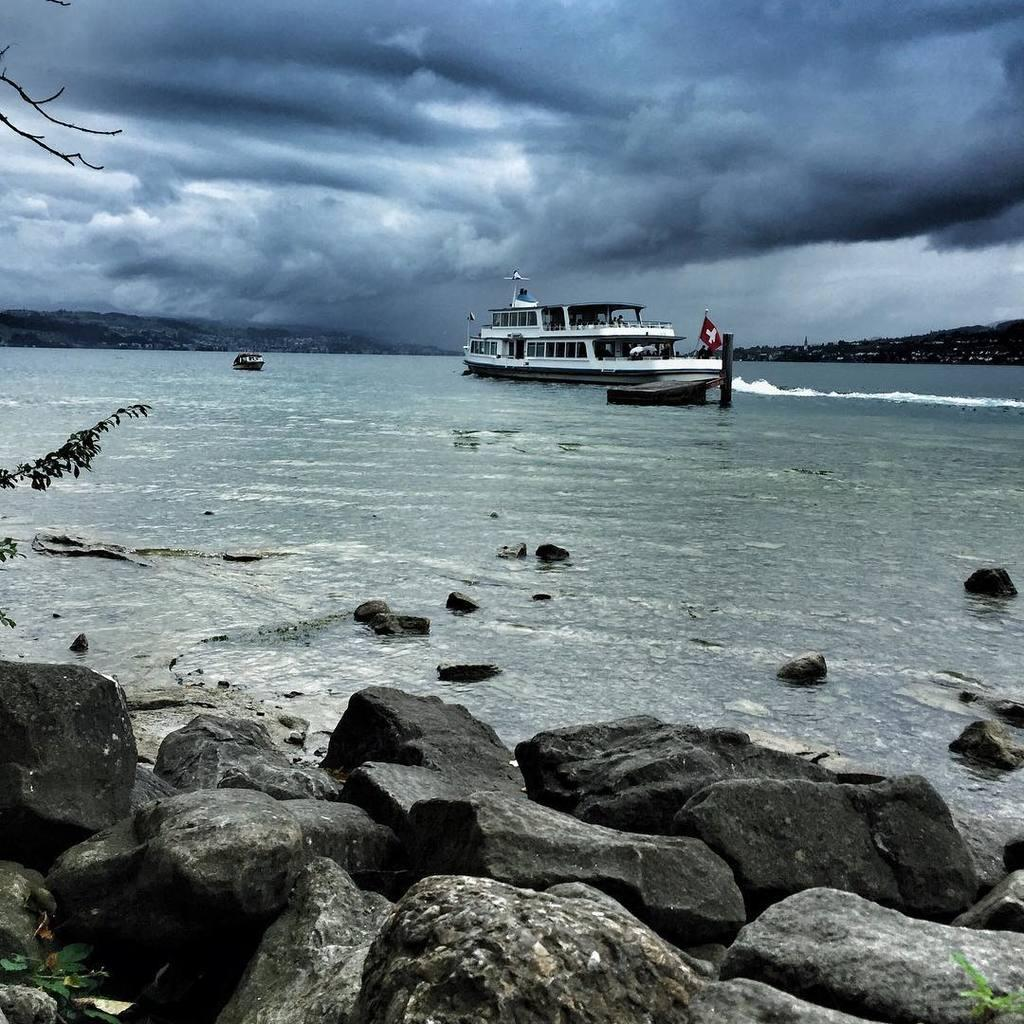What type of vehicles are in the image? There are ships in the image. Where are the ships located? The ships are in a large water body. Can you describe any specific features of the ships? There is a flag on one of the ships. What else can be seen in the image besides the ships? Branches of a tree, stones, hills, and a cloudy sky are visible in the image. Can you tell me how many times the person kicks the ball in the image? There is no person or ball present in the image; it features ships in a large water body. What type of back is visible in the image? There is no back visible in the image; it primarily shows ships, a large water body, and other natural elements. 